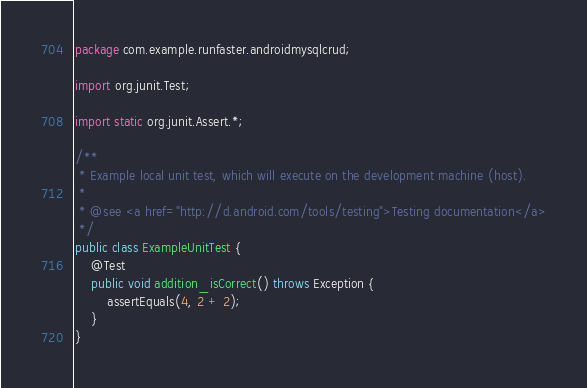<code> <loc_0><loc_0><loc_500><loc_500><_Java_>package com.example.runfaster.androidmysqlcrud;

import org.junit.Test;

import static org.junit.Assert.*;

/**
 * Example local unit test, which will execute on the development machine (host).
 *
 * @see <a href="http://d.android.com/tools/testing">Testing documentation</a>
 */
public class ExampleUnitTest {
    @Test
    public void addition_isCorrect() throws Exception {
        assertEquals(4, 2 + 2);
    }
}</code> 